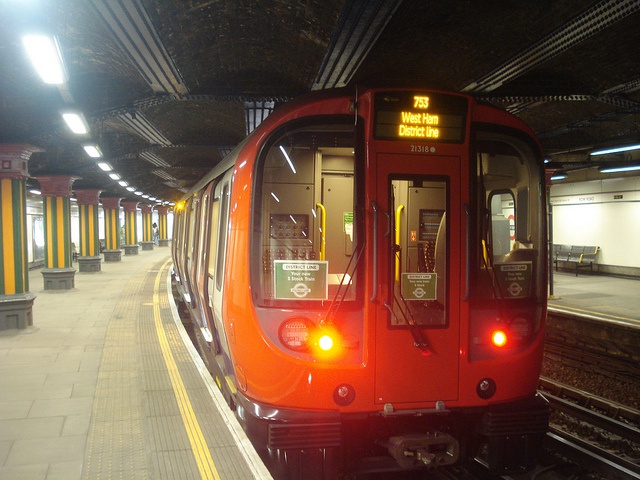Describe the objects in this image and their specific colors. I can see train in lightblue, maroon, black, brown, and red tones and bench in lightblue, gray, black, and darkgray tones in this image. 